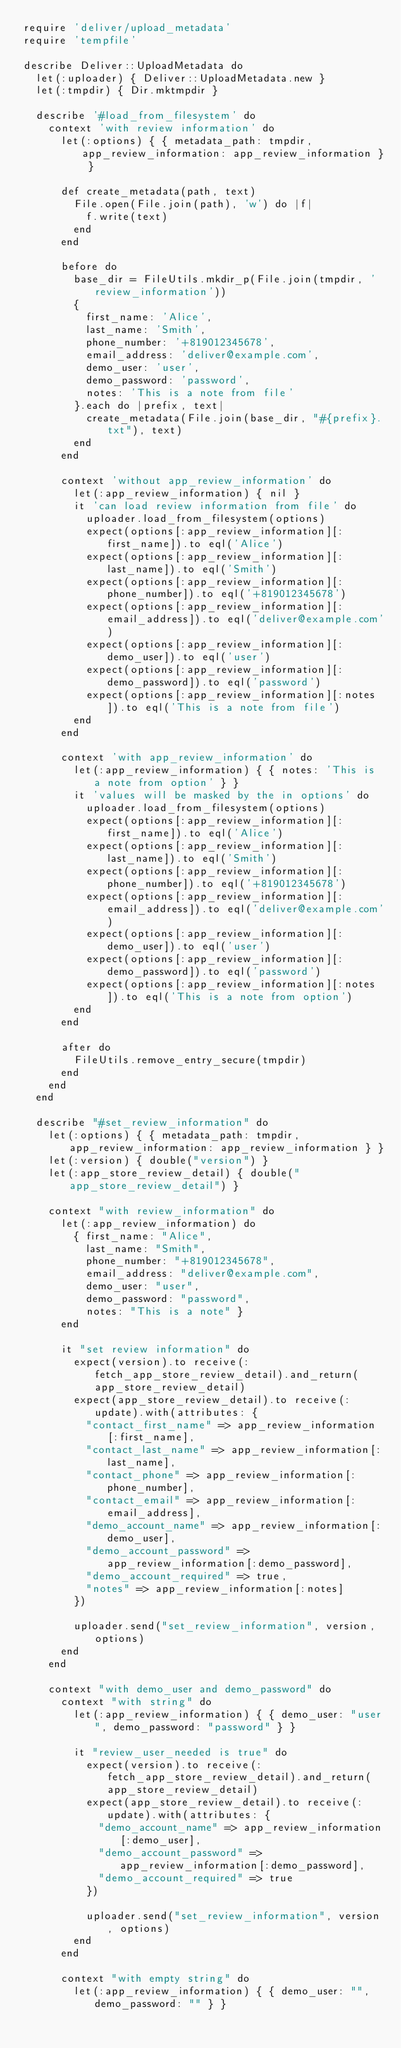Convert code to text. <code><loc_0><loc_0><loc_500><loc_500><_Ruby_>require 'deliver/upload_metadata'
require 'tempfile'

describe Deliver::UploadMetadata do
  let(:uploader) { Deliver::UploadMetadata.new }
  let(:tmpdir) { Dir.mktmpdir }

  describe '#load_from_filesystem' do
    context 'with review information' do
      let(:options) { { metadata_path: tmpdir, app_review_information: app_review_information } }

      def create_metadata(path, text)
        File.open(File.join(path), 'w') do |f|
          f.write(text)
        end
      end

      before do
        base_dir = FileUtils.mkdir_p(File.join(tmpdir, 'review_information'))
        {
          first_name: 'Alice',
          last_name: 'Smith',
          phone_number: '+819012345678',
          email_address: 'deliver@example.com',
          demo_user: 'user',
          demo_password: 'password',
          notes: 'This is a note from file'
        }.each do |prefix, text|
          create_metadata(File.join(base_dir, "#{prefix}.txt"), text)
        end
      end

      context 'without app_review_information' do
        let(:app_review_information) { nil }
        it 'can load review information from file' do
          uploader.load_from_filesystem(options)
          expect(options[:app_review_information][:first_name]).to eql('Alice')
          expect(options[:app_review_information][:last_name]).to eql('Smith')
          expect(options[:app_review_information][:phone_number]).to eql('+819012345678')
          expect(options[:app_review_information][:email_address]).to eql('deliver@example.com')
          expect(options[:app_review_information][:demo_user]).to eql('user')
          expect(options[:app_review_information][:demo_password]).to eql('password')
          expect(options[:app_review_information][:notes]).to eql('This is a note from file')
        end
      end

      context 'with app_review_information' do
        let(:app_review_information) { { notes: 'This is a note from option' } }
        it 'values will be masked by the in options' do
          uploader.load_from_filesystem(options)
          expect(options[:app_review_information][:first_name]).to eql('Alice')
          expect(options[:app_review_information][:last_name]).to eql('Smith')
          expect(options[:app_review_information][:phone_number]).to eql('+819012345678')
          expect(options[:app_review_information][:email_address]).to eql('deliver@example.com')
          expect(options[:app_review_information][:demo_user]).to eql('user')
          expect(options[:app_review_information][:demo_password]).to eql('password')
          expect(options[:app_review_information][:notes]).to eql('This is a note from option')
        end
      end

      after do
        FileUtils.remove_entry_secure(tmpdir)
      end
    end
  end

  describe "#set_review_information" do
    let(:options) { { metadata_path: tmpdir, app_review_information: app_review_information } }
    let(:version) { double("version") }
    let(:app_store_review_detail) { double("app_store_review_detail") }

    context "with review_information" do
      let(:app_review_information) do
        { first_name: "Alice",
          last_name: "Smith",
          phone_number: "+819012345678",
          email_address: "deliver@example.com",
          demo_user: "user",
          demo_password: "password",
          notes: "This is a note" }
      end

      it "set review information" do
        expect(version).to receive(:fetch_app_store_review_detail).and_return(app_store_review_detail)
        expect(app_store_review_detail).to receive(:update).with(attributes: {
          "contact_first_name" => app_review_information[:first_name],
          "contact_last_name" => app_review_information[:last_name],
          "contact_phone" => app_review_information[:phone_number],
          "contact_email" => app_review_information[:email_address],
          "demo_account_name" => app_review_information[:demo_user],
          "demo_account_password" => app_review_information[:demo_password],
          "demo_account_required" => true,
          "notes" => app_review_information[:notes]
        })

        uploader.send("set_review_information", version, options)
      end
    end

    context "with demo_user and demo_password" do
      context "with string" do
        let(:app_review_information) { { demo_user: "user", demo_password: "password" } }

        it "review_user_needed is true" do
          expect(version).to receive(:fetch_app_store_review_detail).and_return(app_store_review_detail)
          expect(app_store_review_detail).to receive(:update).with(attributes: {
            "demo_account_name" => app_review_information[:demo_user],
            "demo_account_password" => app_review_information[:demo_password],
            "demo_account_required" => true
          })

          uploader.send("set_review_information", version, options)
        end
      end

      context "with empty string" do
        let(:app_review_information) { { demo_user: "", demo_password: "" } }
</code> 